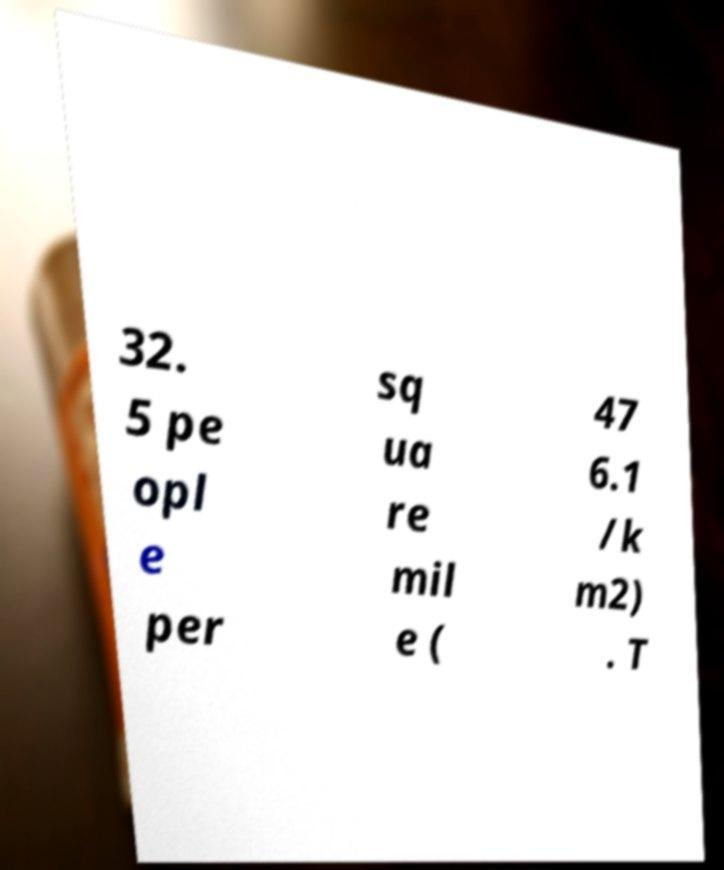Could you extract and type out the text from this image? 32. 5 pe opl e per sq ua re mil e ( 47 6.1 /k m2) . T 